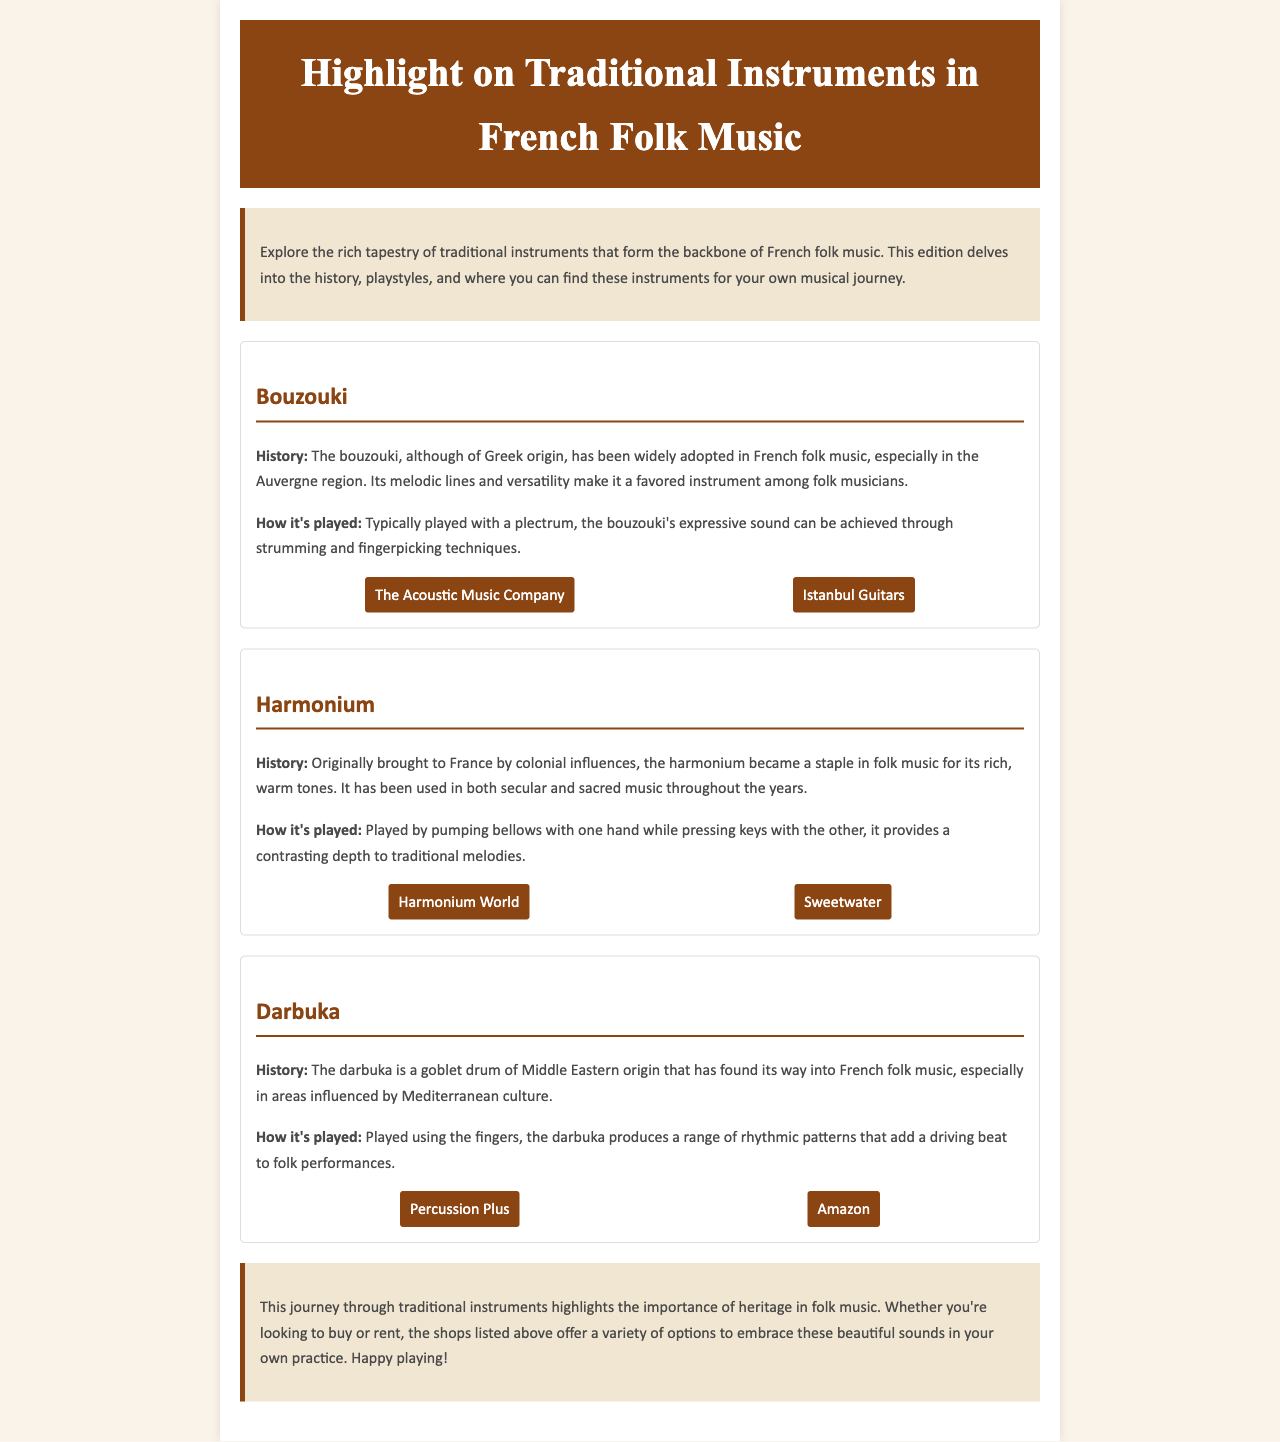What is the title of the newsletter? The title can be found in the header section of the document.
Answer: Highlight on Traditional Instruments in French Folk Music How many instruments are featured in the document? The document highlights three traditional instruments.
Answer: Three What instrument is played with a plectrum? The instrument related to the use of a plectrum is mentioned in the bouzouki section.
Answer: Bouzouki Where can you purchase a harmonium? The document lists sources for purchasing a harmonium in the sources section.
Answer: Harmonium World, Sweetwater What is the primary playing technique for the darbuka? The technique utilized for playing the darbuka is discussed in the respective section.
Answer: Fingers What historical influence is noted for the harmonium? The section on the harmonium mentions the origin of this influence.
Answer: Colonial influences Which instrument is described as having been adopted in the Auvergne region? The specific region associated with the adoption of the instrument is mentioned in the bouzouki section.
Answer: Bouzouki What is the background color of the intro section? The background color of the intro section is described in the style section of the document.
Answer: #f0e6d2 